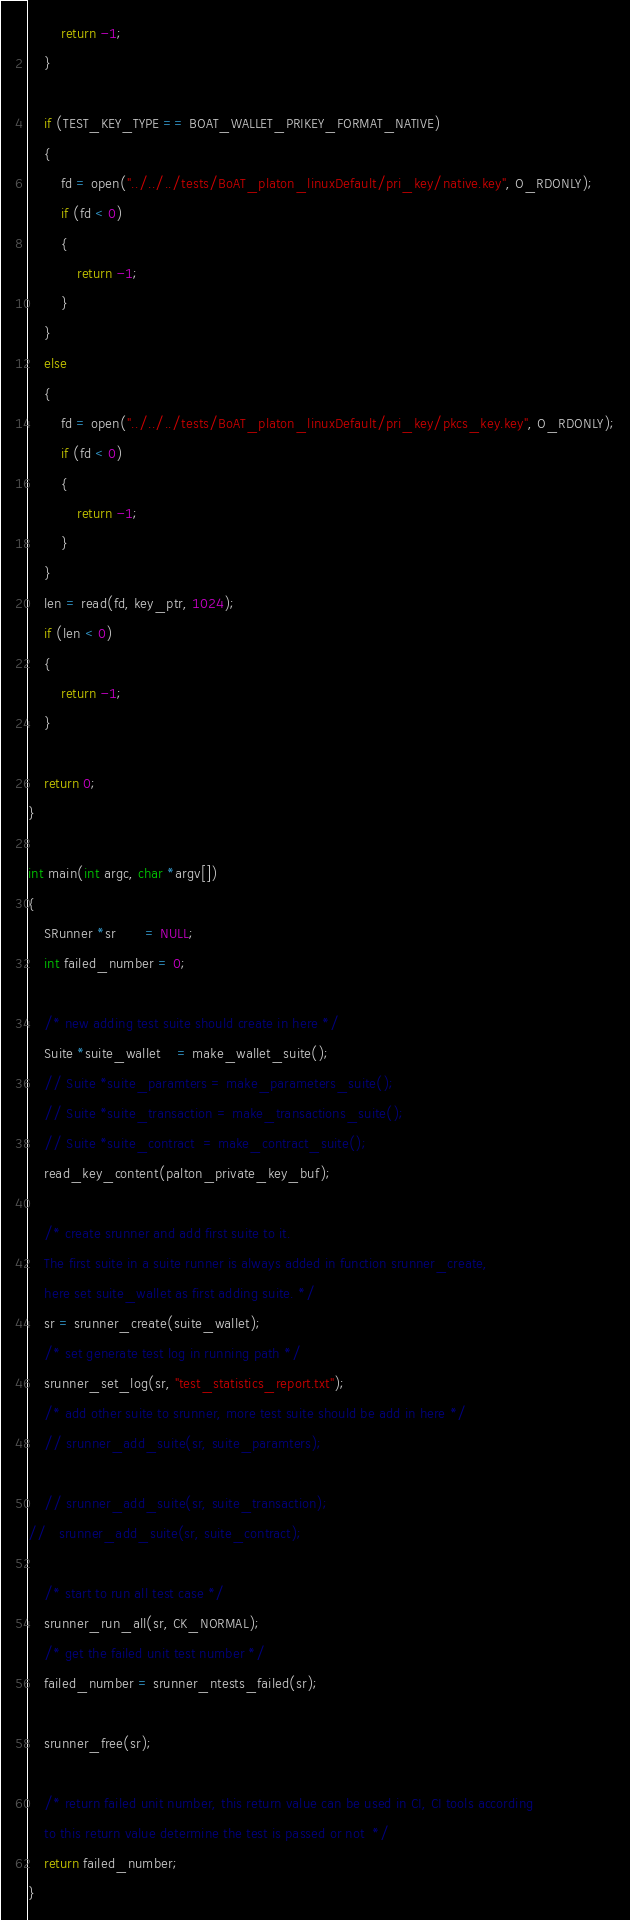<code> <loc_0><loc_0><loc_500><loc_500><_C_>        return -1;
    }

    if (TEST_KEY_TYPE == BOAT_WALLET_PRIKEY_FORMAT_NATIVE)
    {
        fd = open("../../../tests/BoAT_platon_linuxDefault/pri_key/native.key", O_RDONLY);
        if (fd < 0)
        {
            return -1;
        }
    }
    else
    {
        fd = open("../../../tests/BoAT_platon_linuxDefault/pri_key/pkcs_key.key", O_RDONLY);
        if (fd < 0)
        {
            return -1;
        }
    }
    len = read(fd, key_ptr, 1024);
    if (len < 0)
    {
        return -1;
    }
   
    return 0;
}

int main(int argc, char *argv[])
{
    SRunner *sr       = NULL;
    int failed_number = 0;

    /* new adding test suite should create in here */
    Suite *suite_wallet    = make_wallet_suite();
    // Suite *suite_paramters = make_parameters_suite();
    // Suite *suite_transaction = make_transactions_suite();
    // Suite *suite_contract  = make_contract_suite();
    read_key_content(palton_private_key_buf);

    /* create srunner and add first suite to it.
    The first suite in a suite runner is always added in function srunner_create,
    here set suite_wallet as first adding suite. */
    sr = srunner_create(suite_wallet);
    /* set generate test log in running path */
    srunner_set_log(sr, "test_statistics_report.txt");
    /* add other suite to srunner, more test suite should be add in here */
    // srunner_add_suite(sr, suite_paramters);

    // srunner_add_suite(sr, suite_transaction);
//   srunner_add_suite(sr, suite_contract);

    /* start to run all test case */
    srunner_run_all(sr, CK_NORMAL);
    /* get the failed unit test number */
    failed_number = srunner_ntests_failed(sr);

    srunner_free(sr);

    /* return failed unit number, this return value can be used in CI, CI tools according
    to this return value determine the test is passed or not  */
    return failed_number;
}
</code> 